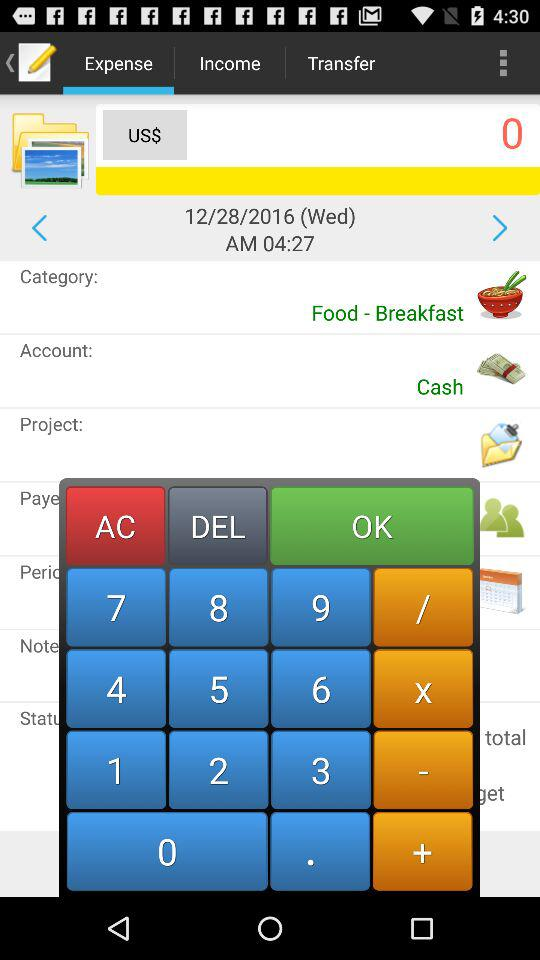What is the category of this transaction?
Answer the question using a single word or phrase. Food - Breakfast 